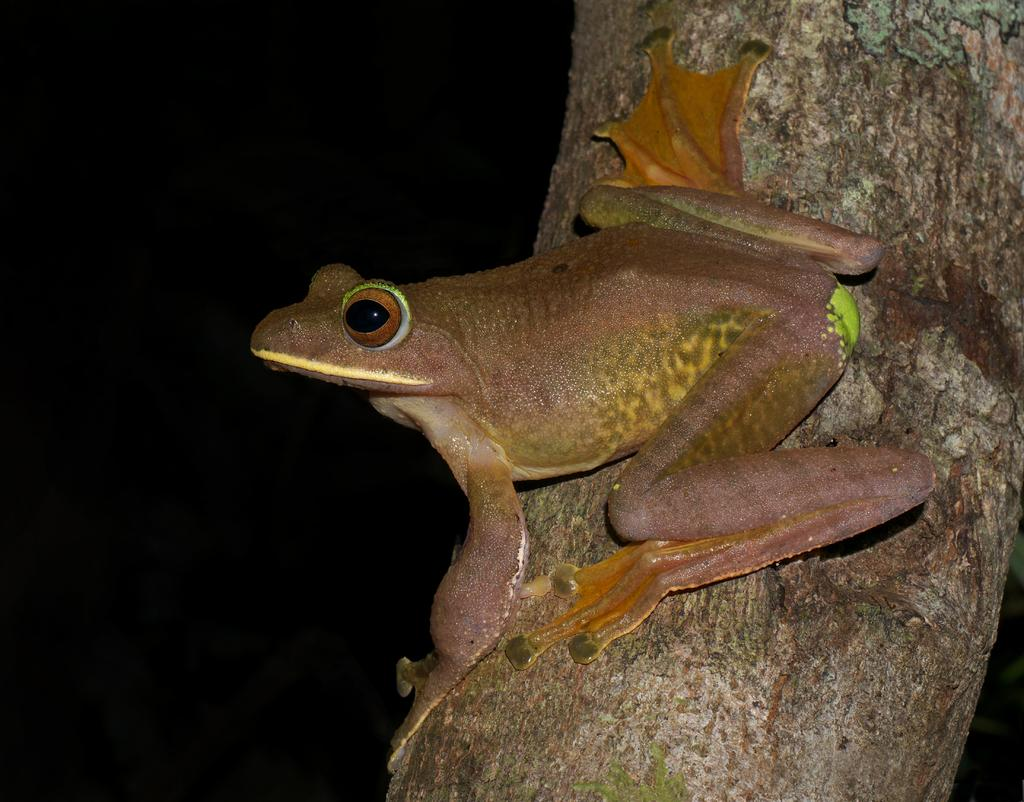What animal is present in the picture? There is a frog in the picture. Where is the frog located? The frog is on the bark of a tree. What type of truck can be seen in the picture? There is no truck present in the picture; it only features a frog on the bark of a tree. 